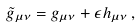Convert formula to latex. <formula><loc_0><loc_0><loc_500><loc_500>\tilde { g } _ { \mu \nu } = g _ { \mu \nu } + \epsilon h _ { \mu \nu } \, ,</formula> 